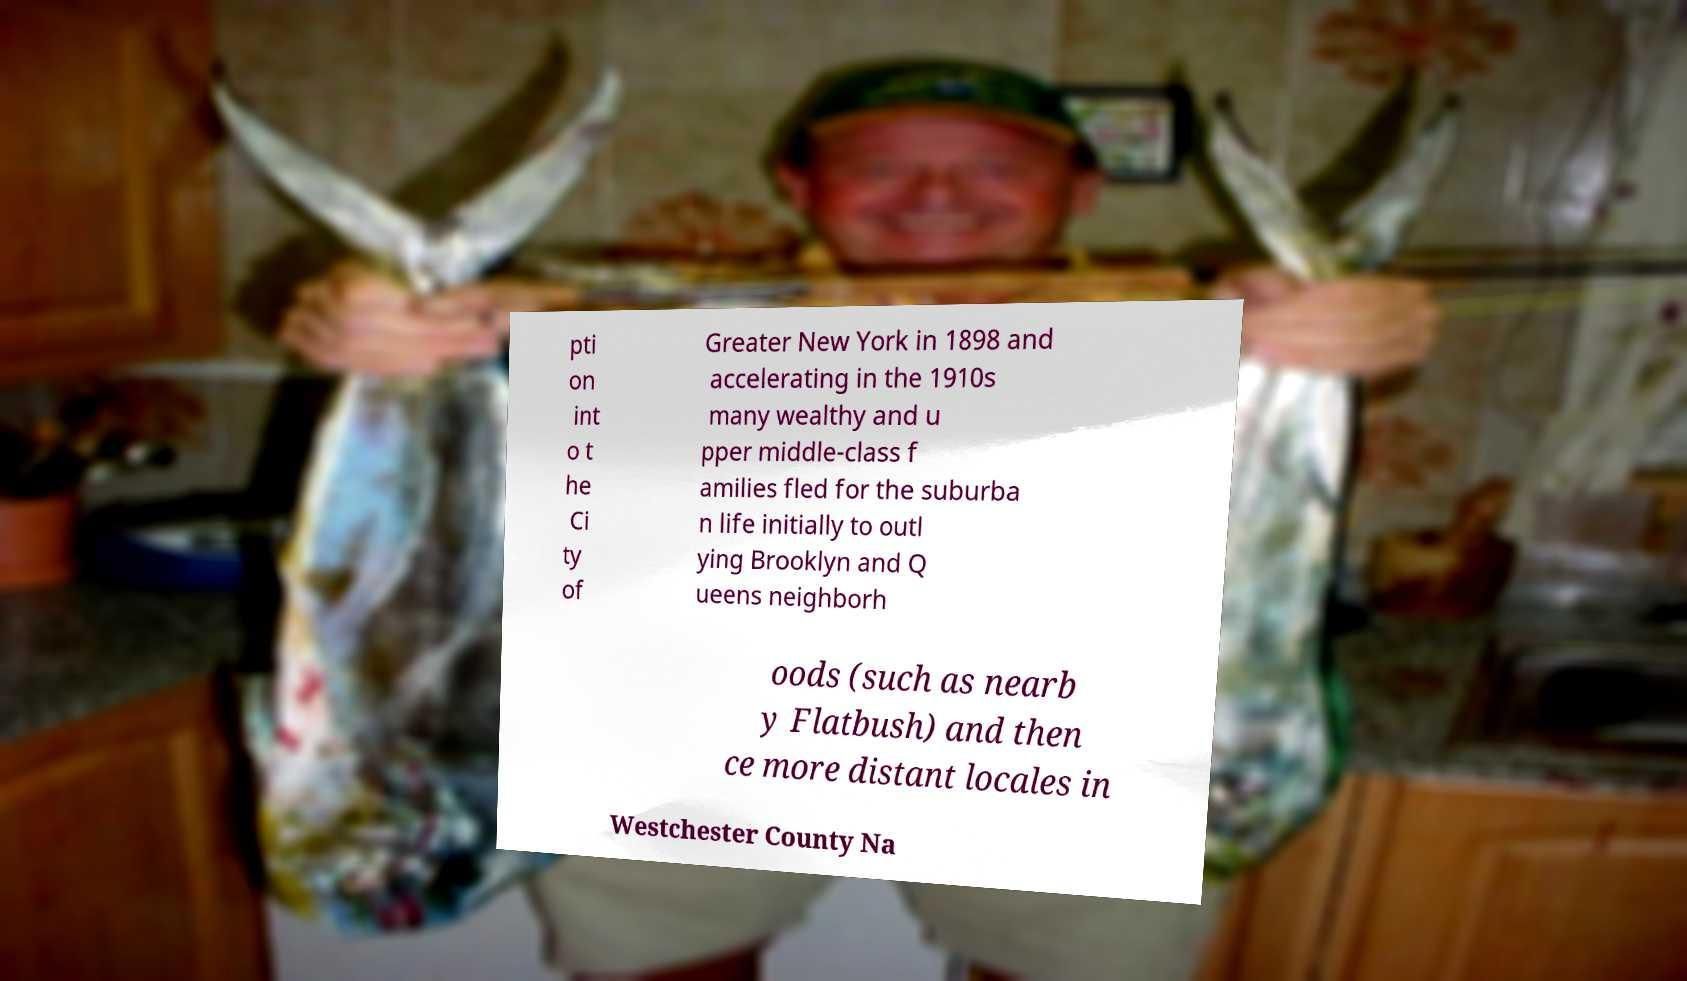Could you assist in decoding the text presented in this image and type it out clearly? pti on int o t he Ci ty of Greater New York in 1898 and accelerating in the 1910s many wealthy and u pper middle-class f amilies fled for the suburba n life initially to outl ying Brooklyn and Q ueens neighborh oods (such as nearb y Flatbush) and then ce more distant locales in Westchester County Na 